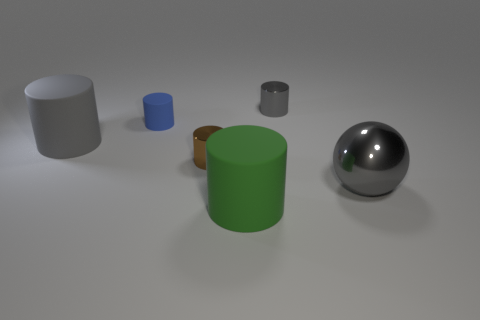Subtract all brown cubes. How many gray cylinders are left? 2 Subtract all green cylinders. How many cylinders are left? 4 Add 4 green matte blocks. How many objects exist? 10 Subtract all brown cylinders. How many cylinders are left? 4 Subtract 3 cylinders. How many cylinders are left? 2 Subtract all cylinders. How many objects are left? 1 Add 1 large red cylinders. How many large red cylinders exist? 1 Subtract 1 gray cylinders. How many objects are left? 5 Subtract all brown cylinders. Subtract all brown balls. How many cylinders are left? 4 Subtract all big cyan blocks. Subtract all small blue cylinders. How many objects are left? 5 